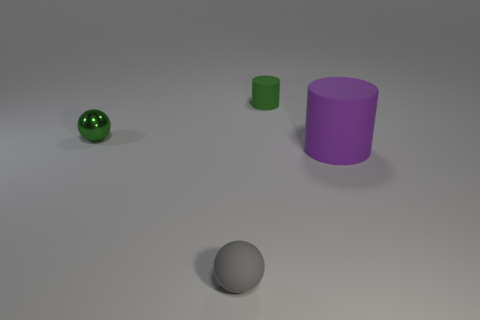Add 4 large red rubber cubes. How many objects exist? 8 Add 4 tiny matte cylinders. How many tiny matte cylinders are left? 5 Add 2 metal objects. How many metal objects exist? 3 Subtract 1 gray spheres. How many objects are left? 3 Subtract all green matte cylinders. Subtract all spheres. How many objects are left? 1 